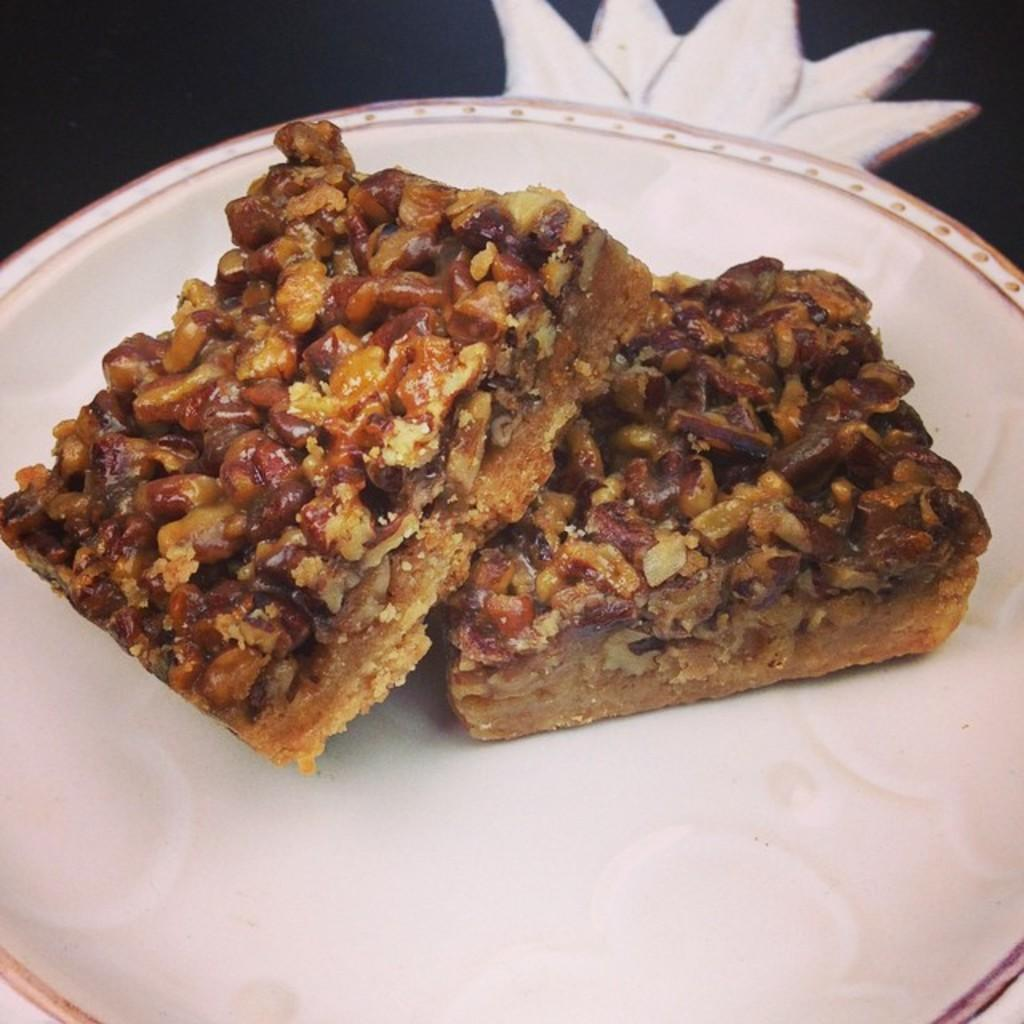What is the main subject of the image? There is a food item in the image. How is the food item presented in the image? The food item is placed on a plate. What type of dock can be seen near the food item in the image? There is no dock present in the image; it only features a food item placed on a plate. 